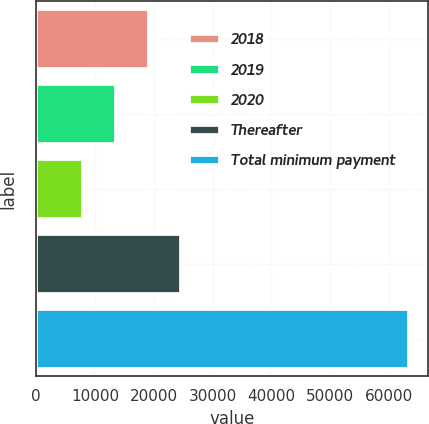<chart> <loc_0><loc_0><loc_500><loc_500><bar_chart><fcel>2018<fcel>2019<fcel>2020<fcel>Thereafter<fcel>Total minimum payment<nl><fcel>19120<fcel>13578<fcel>8036<fcel>24662<fcel>63456<nl></chart> 